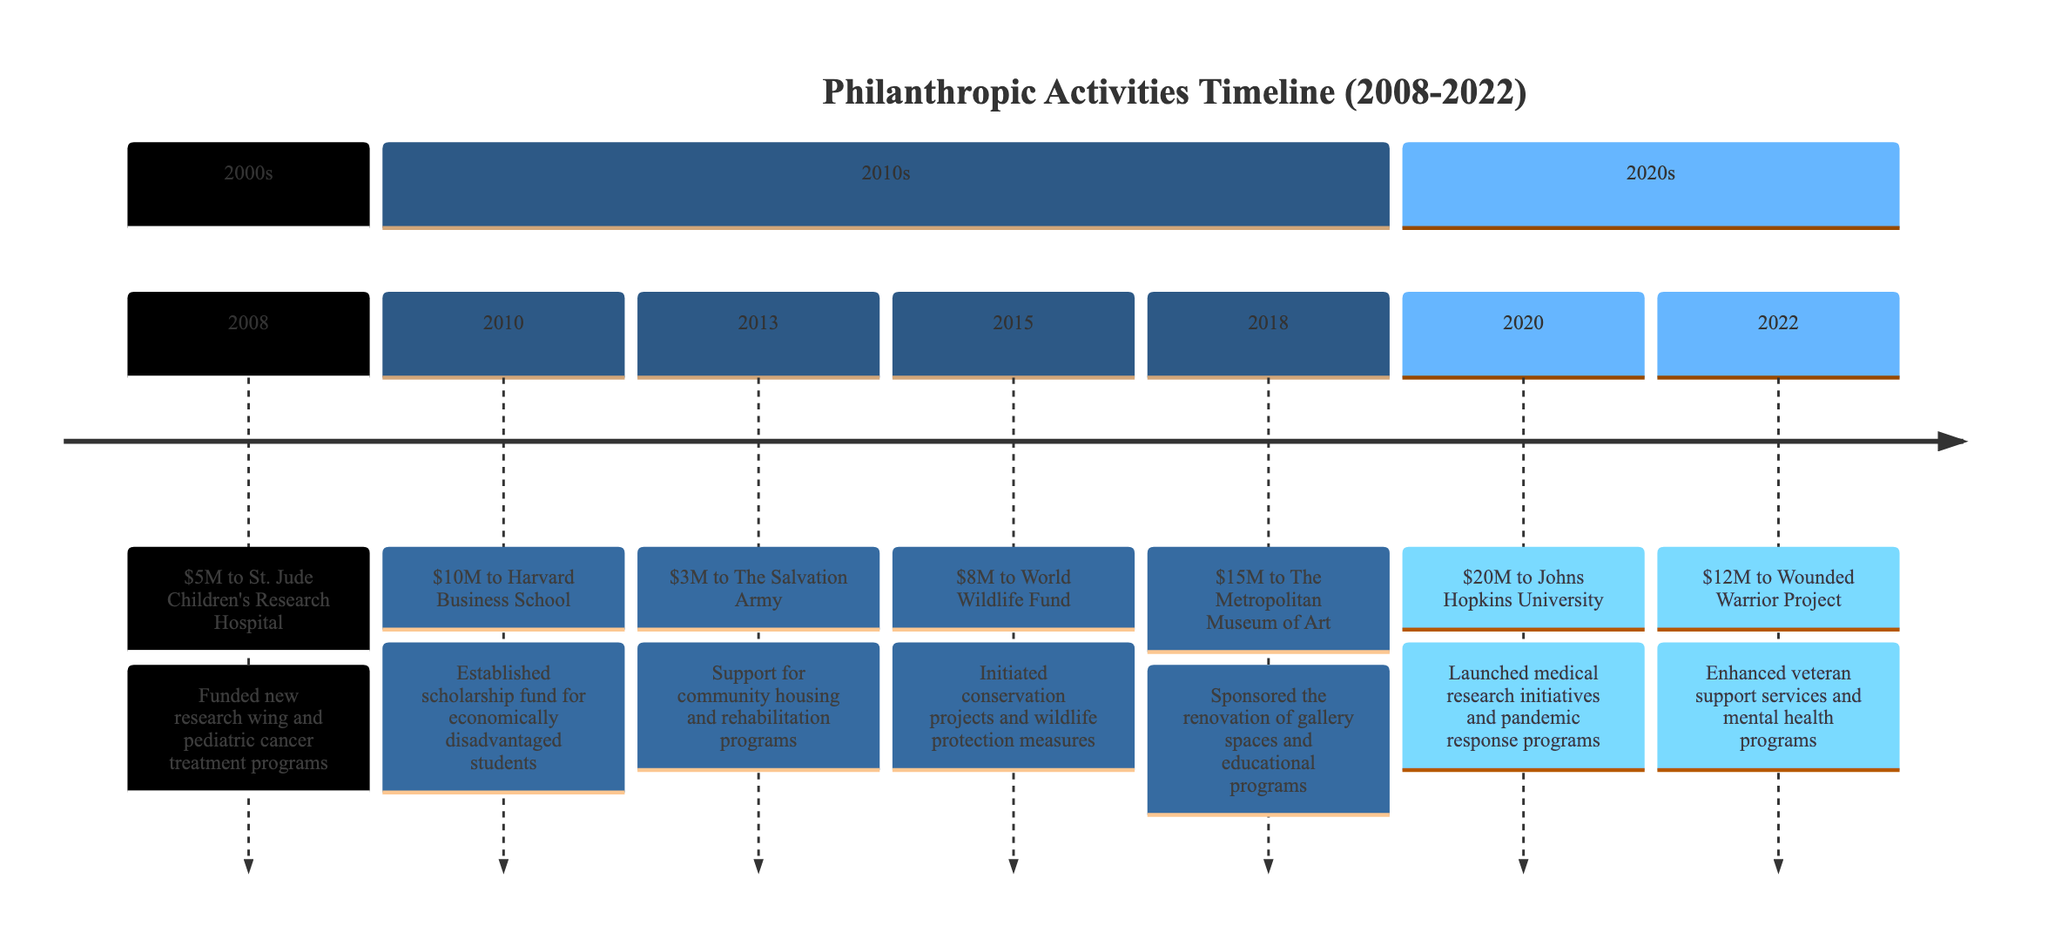What organization received a donation in 2008? The diagram clearly indicates that in 2008, St. Jude Children's Research Hospital received a donation. The corresponding node specifically states this organization and the amount donated.
Answer: St. Jude Children's Research Hospital How much was donated to Harvard Business School? According to the node dedicated to the year 2010, the amount donated to Harvard Business School is explicitly listed adjacent to the organization's name.
Answer: $10 million What was the social impact of the donation to The Salvation Army? By examining the entry for 2013, we see the donation amount to The Salvation Army and the attached description detailing its social impact, which includes community housing and rehabilitation support.
Answer: Support for community housing and rehabilitation programs Which year had the highest donation amount? Reviewing all the years and comparing their donation amounts, 2020 stands out with a donation of $20 million, which is the highest when contrasted against the other entries.
Answer: 2020 How many organizations received donations from 2008 to 2022? Counting the organizations listed in the timeline from the years 2008 to 2022, we identify each unique benefitting organization mentioned, which totals up to seven.
Answer: 7 What was the donation amount to the World Wildlife Fund? The timeline entry for 2015 clearly states the donation amount made to the World Wildlife Fund, providing that specific financial detail directly associated with this organization.
Answer: $8 million What were the social impacts grouped under the 2020s section? In the 2020s section of the diagram, we identify the donations made and their respective social impacts are specifically provided in the descriptions, which can be noted for both Johns Hopkins University and Wounded Warrior Project.
Answer: Launched medical research initiatives and pandemic response programs; Enhanced veteran support services and mental health programs Which organization benefitted in 2018? The timeline indicates that in 2018, The Metropolitan Museum of Art received a donation, which is explicitly mentioned in the corresponding entry for that year.
Answer: The Metropolitan Museum of Art What was the cumulative donation amount from 2008 to 2013? By adding up the donation amounts from 2008 through 2013, we calculate $5 million + $10 million + $3 million + $8 million = $26 million. This cumulative total is obtained by reviewing each year’s entry and performing the arithmetic sum.
Answer: $26 million 